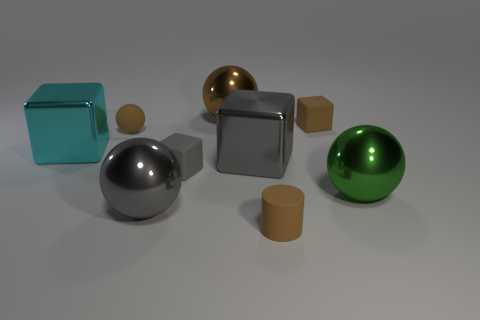Do the cylinder and the small sphere have the same color?
Your answer should be very brief. Yes. There is a large object that is the same color as the matte sphere; what is it made of?
Make the answer very short. Metal. There is a small rubber block that is to the right of the rubber cylinder; is its color the same as the small thing that is in front of the tiny gray thing?
Provide a short and direct response. Yes. Are there any large cyan blocks that have the same material as the large green ball?
Give a very brief answer. Yes. What is the size of the brown ball in front of the tiny matte block behind the large cyan block?
Provide a succinct answer. Small. Is the number of purple blocks greater than the number of large gray metal objects?
Keep it short and to the point. No. There is a metallic sphere behind the cyan object; does it have the same size as the brown block?
Ensure brevity in your answer.  No. How many matte things have the same color as the tiny cylinder?
Give a very brief answer. 2. Does the gray rubber thing have the same shape as the big brown metal object?
Offer a terse response. No. The cyan metal thing that is the same shape as the small gray rubber object is what size?
Your response must be concise. Large. 